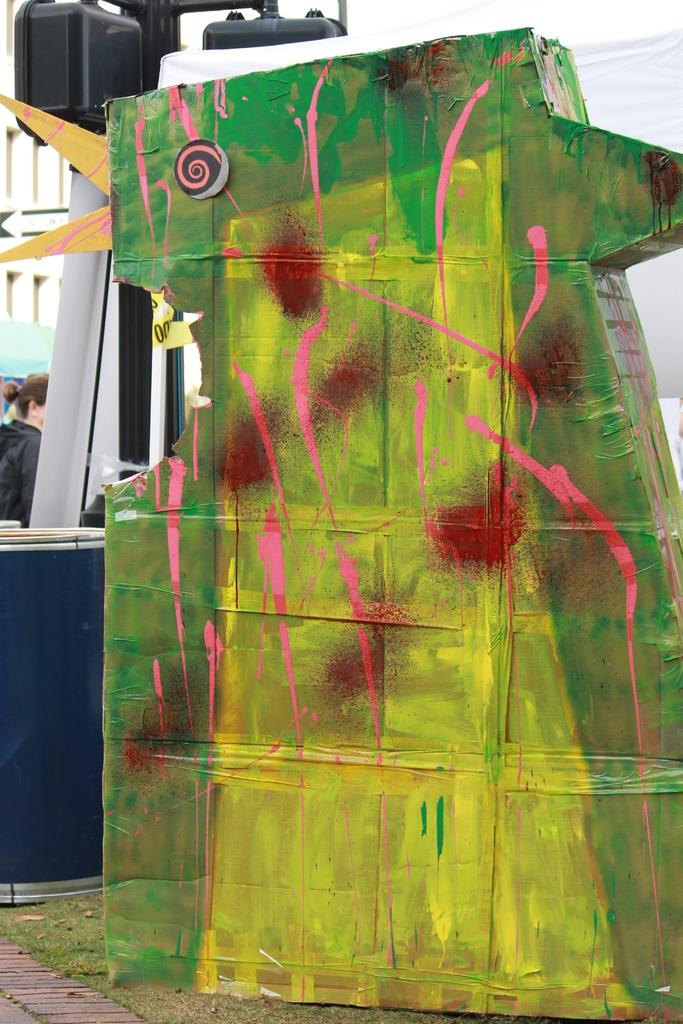What is the green color thing in the image? There is a green color thing in the image, but the specific details are not provided. What type of natural environment can be seen in the image? There is grass visible in the image, which suggests a natural environment. Can you tell me how many seeds are present in the image? There is no information provided about seeds in the image. What type of activity is the green color thing doing in the image? The specific details about the green color thing are not provided, so it is not possible to determine what activity it might be doing. 